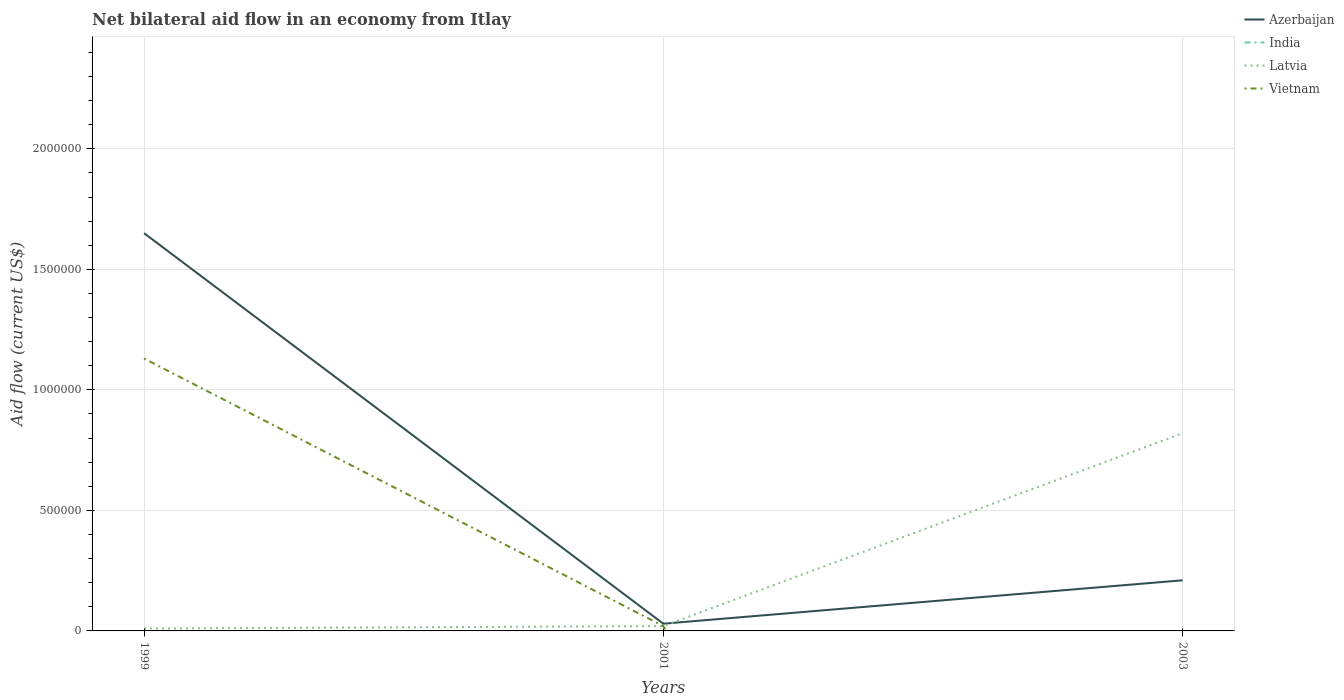How many different coloured lines are there?
Provide a succinct answer. 3. Does the line corresponding to India intersect with the line corresponding to Azerbaijan?
Your response must be concise. No. Across all years, what is the maximum net bilateral aid flow in India?
Offer a very short reply. 0. What is the total net bilateral aid flow in Vietnam in the graph?
Provide a succinct answer. 1.11e+06. What is the difference between the highest and the second highest net bilateral aid flow in Vietnam?
Offer a terse response. 1.13e+06. Is the net bilateral aid flow in Azerbaijan strictly greater than the net bilateral aid flow in Vietnam over the years?
Offer a terse response. No. How many years are there in the graph?
Make the answer very short. 3. How many legend labels are there?
Keep it short and to the point. 4. How are the legend labels stacked?
Provide a short and direct response. Vertical. What is the title of the graph?
Your answer should be very brief. Net bilateral aid flow in an economy from Itlay. What is the Aid flow (current US$) of Azerbaijan in 1999?
Ensure brevity in your answer.  1.65e+06. What is the Aid flow (current US$) in India in 1999?
Provide a short and direct response. 0. What is the Aid flow (current US$) of Latvia in 1999?
Ensure brevity in your answer.  10000. What is the Aid flow (current US$) of Vietnam in 1999?
Provide a short and direct response. 1.13e+06. What is the Aid flow (current US$) in Latvia in 2001?
Make the answer very short. 2.00e+04. What is the Aid flow (current US$) in India in 2003?
Keep it short and to the point. 0. What is the Aid flow (current US$) of Latvia in 2003?
Provide a succinct answer. 8.20e+05. What is the Aid flow (current US$) in Vietnam in 2003?
Make the answer very short. 0. Across all years, what is the maximum Aid flow (current US$) of Azerbaijan?
Offer a terse response. 1.65e+06. Across all years, what is the maximum Aid flow (current US$) of Latvia?
Offer a very short reply. 8.20e+05. Across all years, what is the maximum Aid flow (current US$) in Vietnam?
Offer a very short reply. 1.13e+06. Across all years, what is the minimum Aid flow (current US$) in Azerbaijan?
Keep it short and to the point. 3.00e+04. What is the total Aid flow (current US$) of Azerbaijan in the graph?
Make the answer very short. 1.89e+06. What is the total Aid flow (current US$) in India in the graph?
Offer a very short reply. 0. What is the total Aid flow (current US$) of Latvia in the graph?
Make the answer very short. 8.50e+05. What is the total Aid flow (current US$) of Vietnam in the graph?
Your answer should be compact. 1.15e+06. What is the difference between the Aid flow (current US$) in Azerbaijan in 1999 and that in 2001?
Keep it short and to the point. 1.62e+06. What is the difference between the Aid flow (current US$) of Vietnam in 1999 and that in 2001?
Offer a terse response. 1.11e+06. What is the difference between the Aid flow (current US$) in Azerbaijan in 1999 and that in 2003?
Keep it short and to the point. 1.44e+06. What is the difference between the Aid flow (current US$) of Latvia in 1999 and that in 2003?
Provide a short and direct response. -8.10e+05. What is the difference between the Aid flow (current US$) of Azerbaijan in 2001 and that in 2003?
Your answer should be very brief. -1.80e+05. What is the difference between the Aid flow (current US$) in Latvia in 2001 and that in 2003?
Keep it short and to the point. -8.00e+05. What is the difference between the Aid flow (current US$) of Azerbaijan in 1999 and the Aid flow (current US$) of Latvia in 2001?
Make the answer very short. 1.63e+06. What is the difference between the Aid flow (current US$) of Azerbaijan in 1999 and the Aid flow (current US$) of Vietnam in 2001?
Ensure brevity in your answer.  1.63e+06. What is the difference between the Aid flow (current US$) of Latvia in 1999 and the Aid flow (current US$) of Vietnam in 2001?
Offer a very short reply. -10000. What is the difference between the Aid flow (current US$) of Azerbaijan in 1999 and the Aid flow (current US$) of Latvia in 2003?
Ensure brevity in your answer.  8.30e+05. What is the difference between the Aid flow (current US$) of Azerbaijan in 2001 and the Aid flow (current US$) of Latvia in 2003?
Your answer should be very brief. -7.90e+05. What is the average Aid flow (current US$) in Azerbaijan per year?
Your answer should be compact. 6.30e+05. What is the average Aid flow (current US$) of Latvia per year?
Your answer should be compact. 2.83e+05. What is the average Aid flow (current US$) in Vietnam per year?
Your response must be concise. 3.83e+05. In the year 1999, what is the difference between the Aid flow (current US$) in Azerbaijan and Aid flow (current US$) in Latvia?
Ensure brevity in your answer.  1.64e+06. In the year 1999, what is the difference between the Aid flow (current US$) in Azerbaijan and Aid flow (current US$) in Vietnam?
Ensure brevity in your answer.  5.20e+05. In the year 1999, what is the difference between the Aid flow (current US$) in Latvia and Aid flow (current US$) in Vietnam?
Make the answer very short. -1.12e+06. In the year 2001, what is the difference between the Aid flow (current US$) in Azerbaijan and Aid flow (current US$) in Latvia?
Keep it short and to the point. 10000. In the year 2001, what is the difference between the Aid flow (current US$) in Azerbaijan and Aid flow (current US$) in Vietnam?
Make the answer very short. 10000. In the year 2003, what is the difference between the Aid flow (current US$) in Azerbaijan and Aid flow (current US$) in Latvia?
Offer a terse response. -6.10e+05. What is the ratio of the Aid flow (current US$) of Vietnam in 1999 to that in 2001?
Keep it short and to the point. 56.5. What is the ratio of the Aid flow (current US$) of Azerbaijan in 1999 to that in 2003?
Ensure brevity in your answer.  7.86. What is the ratio of the Aid flow (current US$) in Latvia in 1999 to that in 2003?
Your response must be concise. 0.01. What is the ratio of the Aid flow (current US$) of Azerbaijan in 2001 to that in 2003?
Your answer should be compact. 0.14. What is the ratio of the Aid flow (current US$) of Latvia in 2001 to that in 2003?
Offer a terse response. 0.02. What is the difference between the highest and the second highest Aid flow (current US$) of Azerbaijan?
Your response must be concise. 1.44e+06. What is the difference between the highest and the second highest Aid flow (current US$) in Latvia?
Offer a terse response. 8.00e+05. What is the difference between the highest and the lowest Aid flow (current US$) of Azerbaijan?
Offer a terse response. 1.62e+06. What is the difference between the highest and the lowest Aid flow (current US$) in Latvia?
Your answer should be very brief. 8.10e+05. What is the difference between the highest and the lowest Aid flow (current US$) of Vietnam?
Offer a terse response. 1.13e+06. 